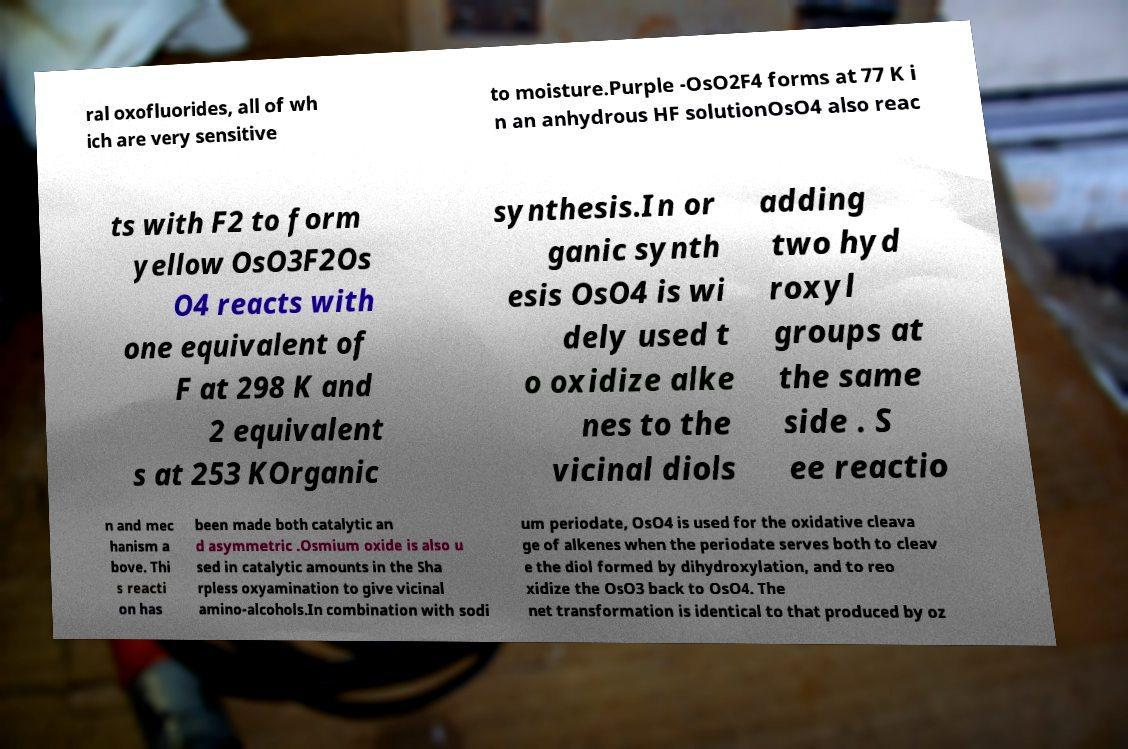Can you read and provide the text displayed in the image?This photo seems to have some interesting text. Can you extract and type it out for me? ral oxofluorides, all of wh ich are very sensitive to moisture.Purple -OsO2F4 forms at 77 K i n an anhydrous HF solutionOsO4 also reac ts with F2 to form yellow OsO3F2Os O4 reacts with one equivalent of F at 298 K and 2 equivalent s at 253 KOrganic synthesis.In or ganic synth esis OsO4 is wi dely used t o oxidize alke nes to the vicinal diols adding two hyd roxyl groups at the same side . S ee reactio n and mec hanism a bove. Thi s reacti on has been made both catalytic an d asymmetric .Osmium oxide is also u sed in catalytic amounts in the Sha rpless oxyamination to give vicinal amino-alcohols.In combination with sodi um periodate, OsO4 is used for the oxidative cleava ge of alkenes when the periodate serves both to cleav e the diol formed by dihydroxylation, and to reo xidize the OsO3 back to OsO4. The net transformation is identical to that produced by oz 